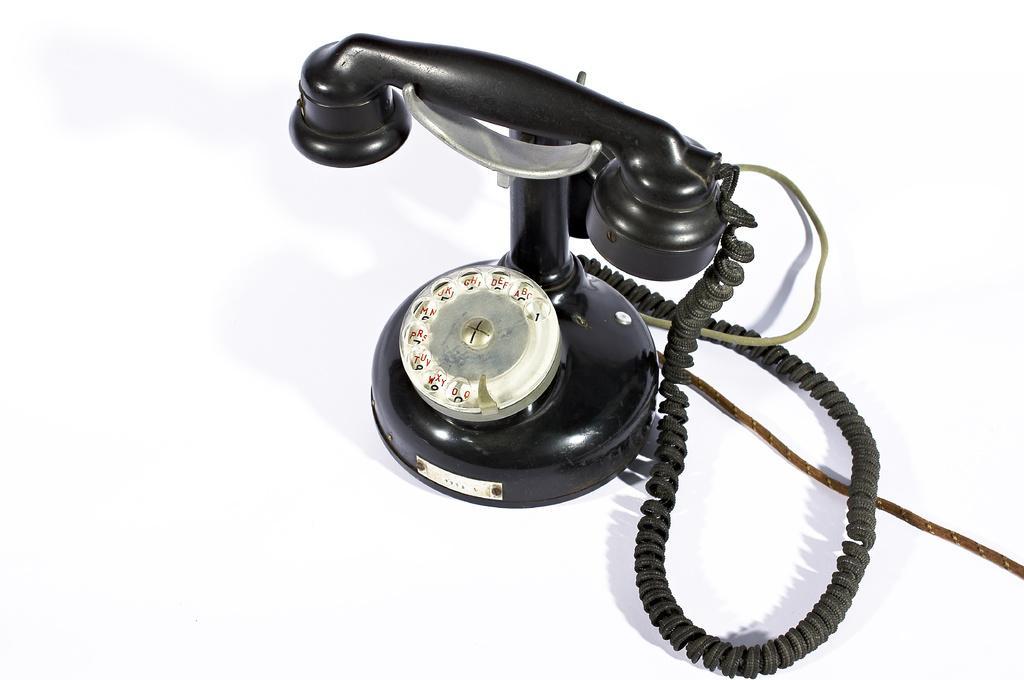Please provide a concise description of this image. In this picture we can see telephone and cables on the white surface. In the background of the image it is white. 